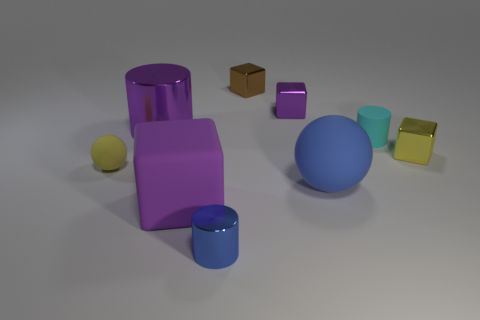There is a matte thing that is the same color as the large metallic cylinder; what size is it?
Offer a terse response. Large. There is a large object that is the same shape as the tiny cyan rubber object; what color is it?
Offer a terse response. Purple. What number of yellow things are right of the tiny cylinder that is behind the big sphere?
Make the answer very short. 1. How many things are tiny metal things that are on the right side of the cyan matte thing or tiny metallic blocks?
Keep it short and to the point. 3. Is there a yellow matte object that has the same shape as the big purple metallic object?
Provide a succinct answer. No. There is a yellow object that is to the left of the large purple cylinder left of the brown metallic object; what is its shape?
Your answer should be very brief. Sphere. What number of cubes are large blue things or cyan things?
Ensure brevity in your answer.  0. There is a tiny cube that is the same color as the big block; what material is it?
Offer a terse response. Metal. Does the tiny thing behind the tiny purple shiny object have the same shape as the yellow object that is to the left of the tiny blue metallic thing?
Ensure brevity in your answer.  No. There is a thing that is behind the tiny cyan object and to the left of the tiny blue shiny object; what color is it?
Keep it short and to the point. Purple. 